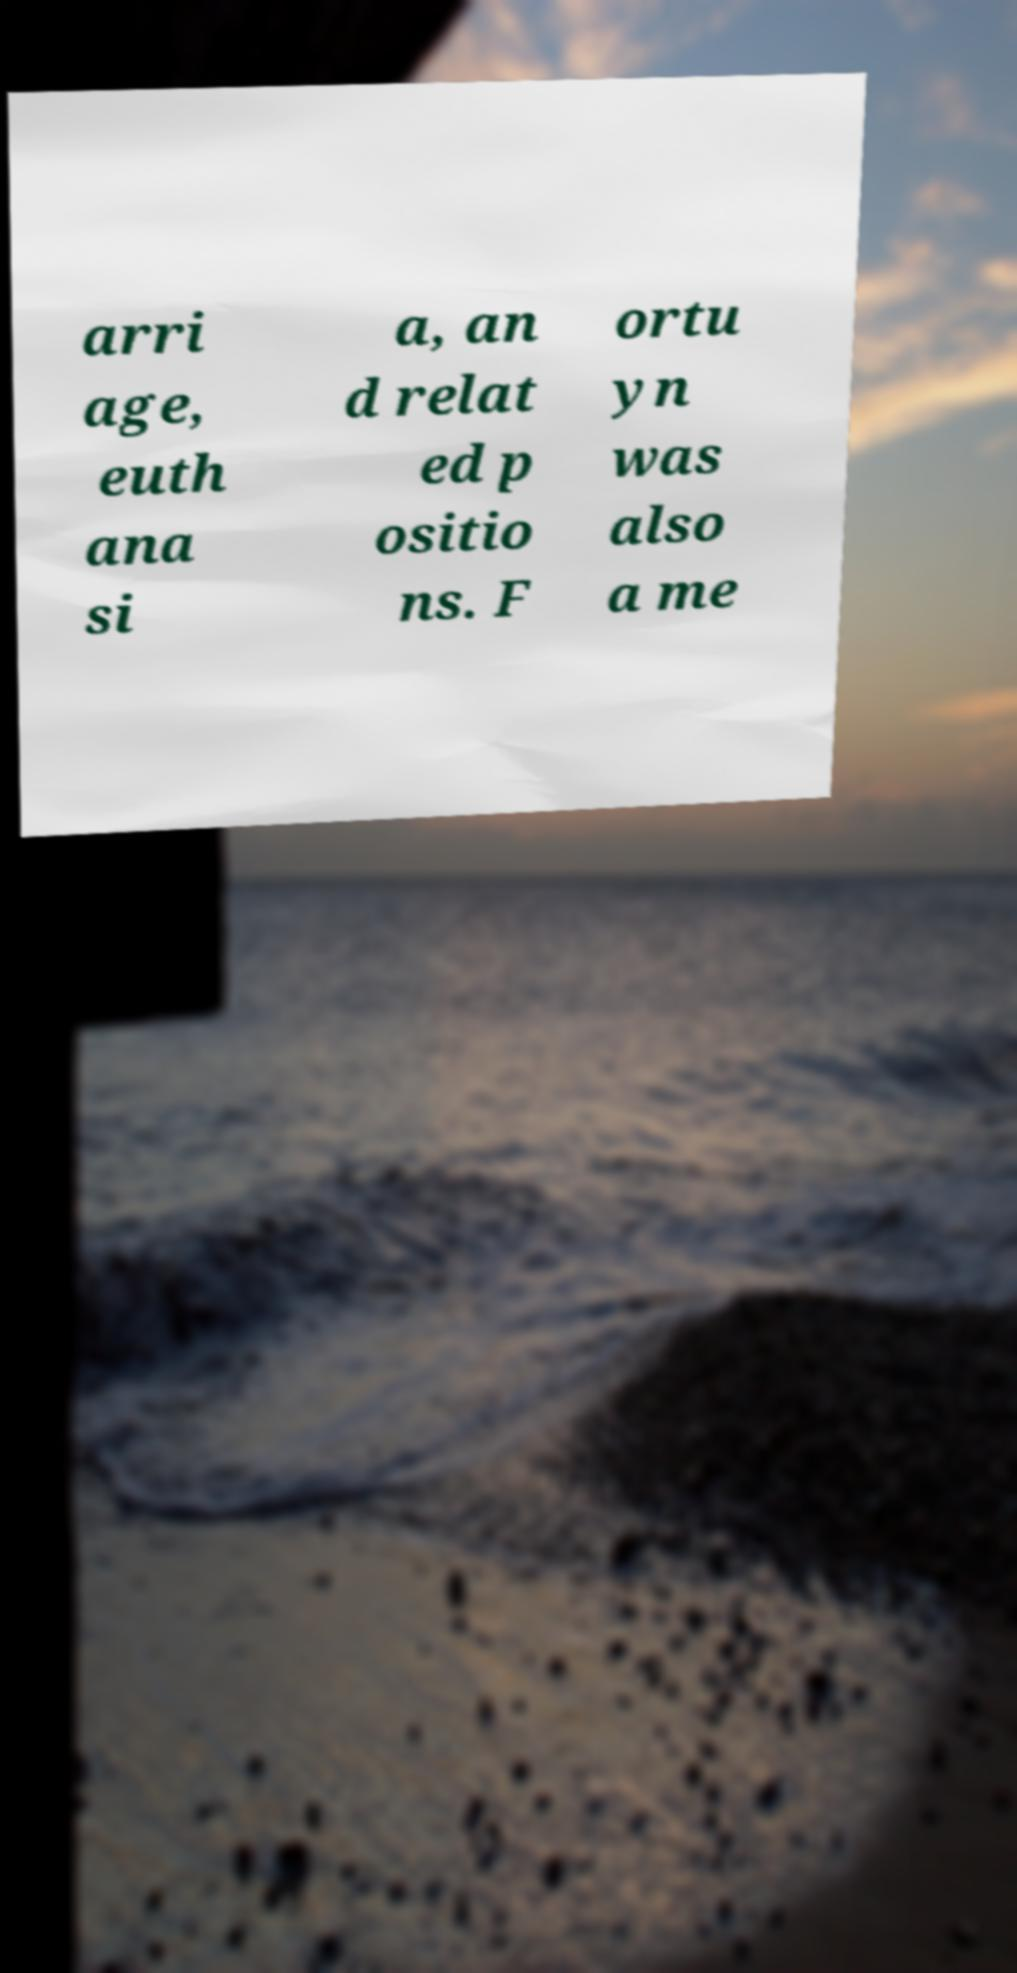Could you extract and type out the text from this image? arri age, euth ana si a, an d relat ed p ositio ns. F ortu yn was also a me 